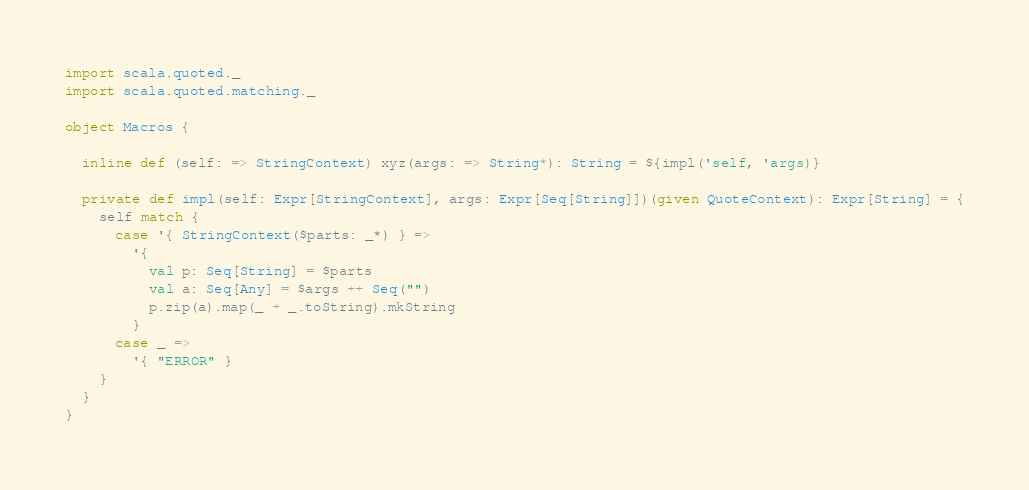<code> <loc_0><loc_0><loc_500><loc_500><_Scala_>import scala.quoted._
import scala.quoted.matching._

object Macros {

  inline def (self: => StringContext) xyz(args: => String*): String = ${impl('self, 'args)}

  private def impl(self: Expr[StringContext], args: Expr[Seq[String]])(given QuoteContext): Expr[String] = {
    self match {
      case '{ StringContext($parts: _*) } =>
        '{
          val p: Seq[String] = $parts
          val a: Seq[Any] = $args ++ Seq("")
          p.zip(a).map(_ + _.toString).mkString
        }
      case _ =>
        '{ "ERROR" }
    }
  }
}
</code> 